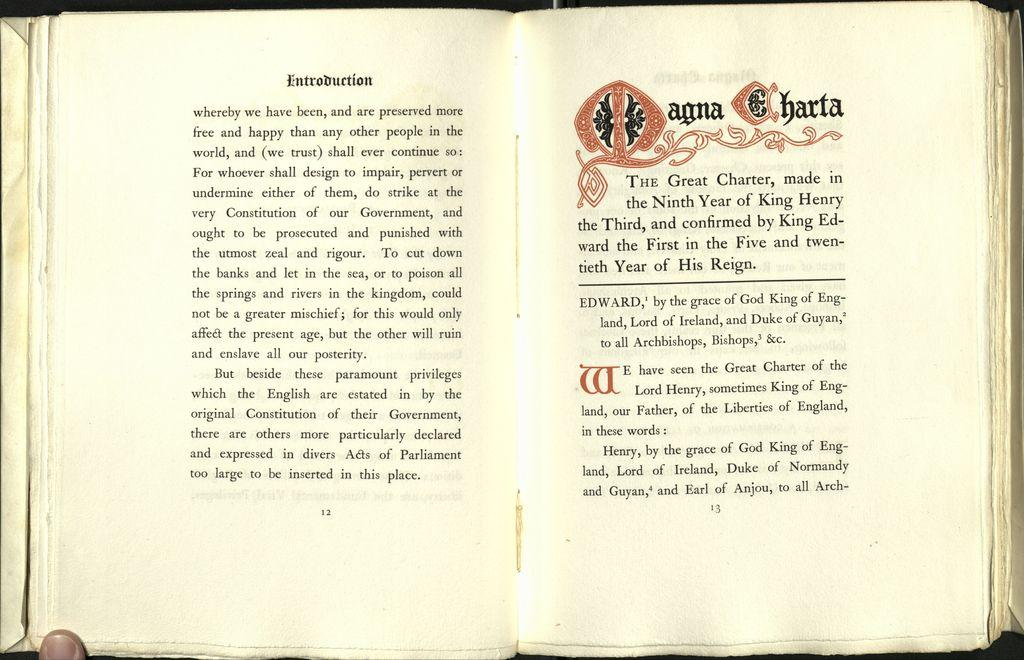What object is present in the image? There is a book in the image. Can you describe the book's appearance? The book has a page visible. What can be seen on the visible page? There is some matter written on the page. How many frogs are jumping on the railway in the image? There are no frogs or railways present in the image; it features a book with a visible page. 